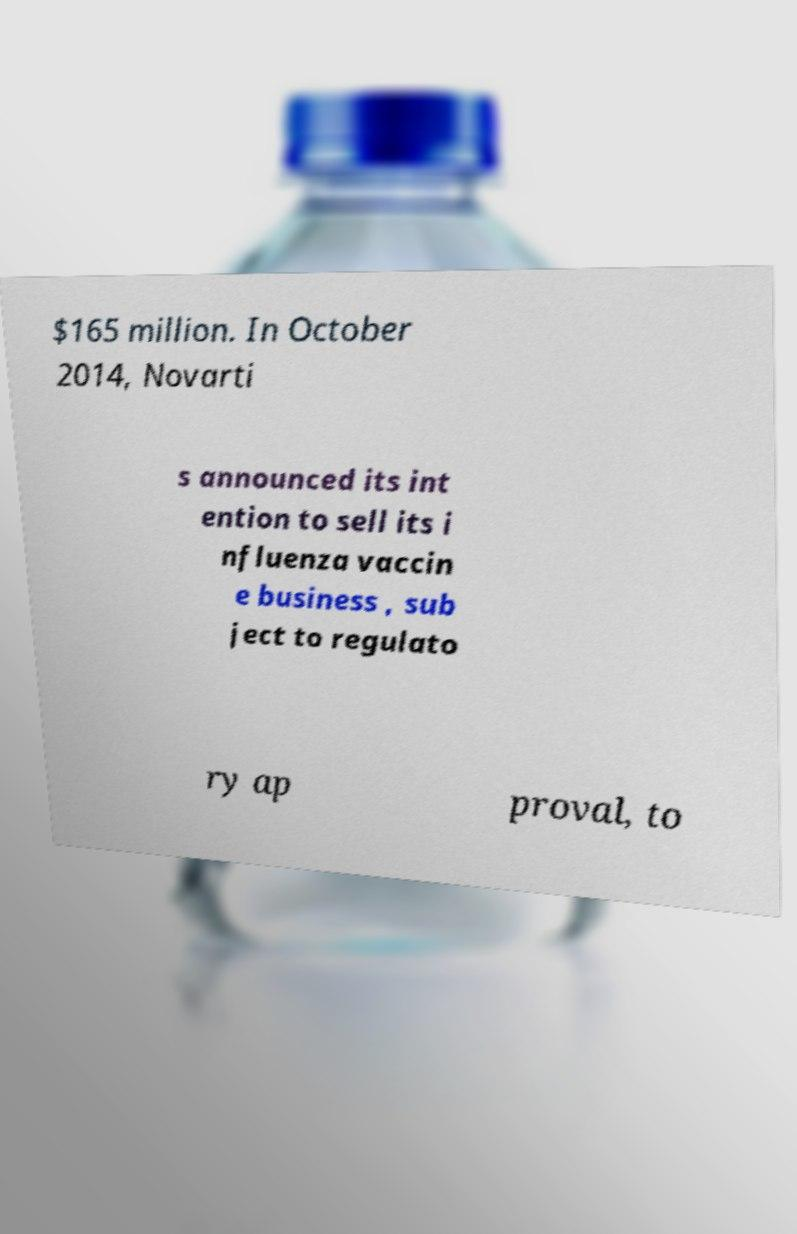Can you read and provide the text displayed in the image?This photo seems to have some interesting text. Can you extract and type it out for me? $165 million. In October 2014, Novarti s announced its int ention to sell its i nfluenza vaccin e business , sub ject to regulato ry ap proval, to 